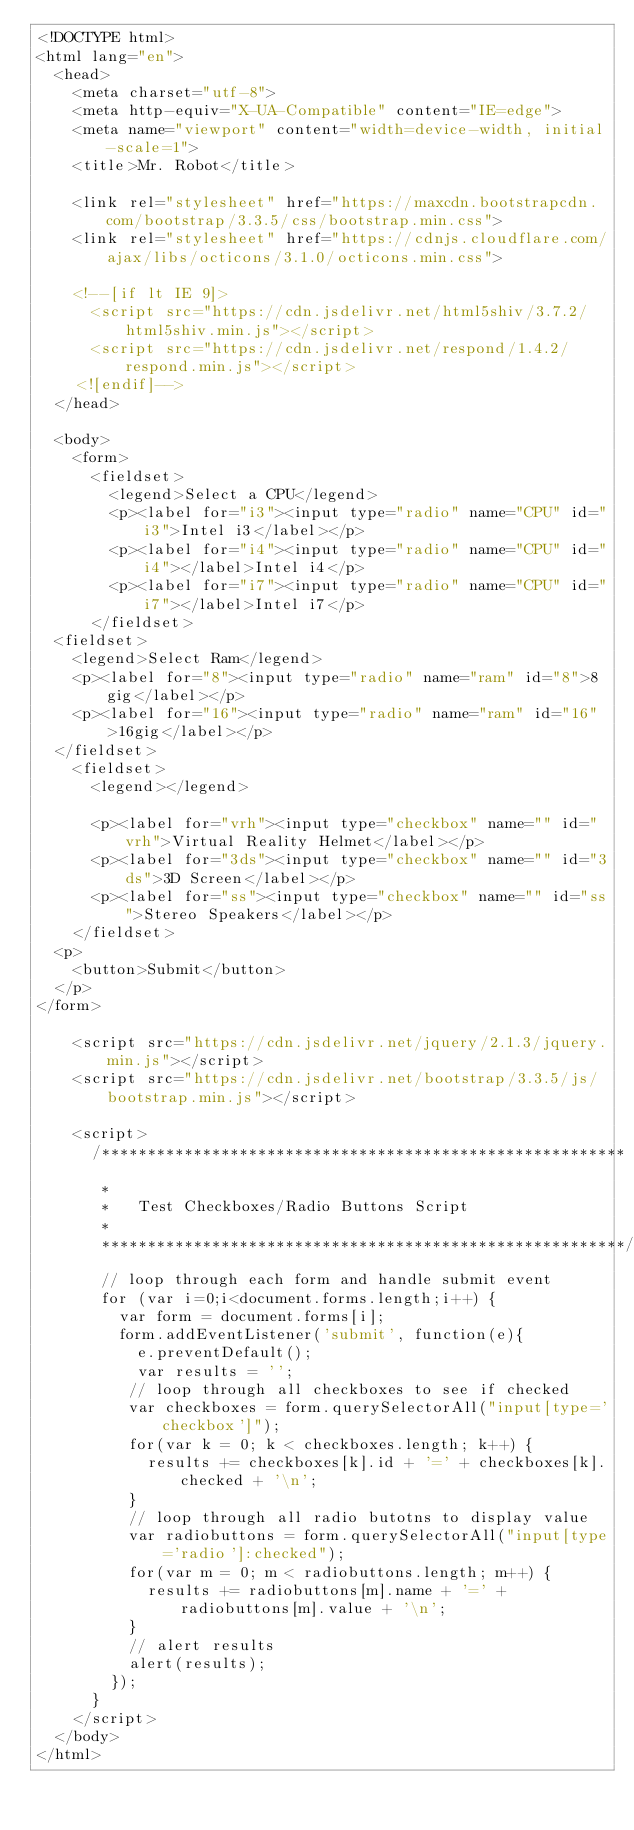<code> <loc_0><loc_0><loc_500><loc_500><_HTML_><!DOCTYPE html>
<html lang="en">
  <head>
    <meta charset="utf-8">
    <meta http-equiv="X-UA-Compatible" content="IE=edge">
    <meta name="viewport" content="width=device-width, initial-scale=1">
    <title>Mr. Robot</title>

    <link rel="stylesheet" href="https://maxcdn.bootstrapcdn.com/bootstrap/3.3.5/css/bootstrap.min.css">
    <link rel="stylesheet" href="https://cdnjs.cloudflare.com/ajax/libs/octicons/3.1.0/octicons.min.css">

    <!--[if lt IE 9]>
      <script src="https://cdn.jsdelivr.net/html5shiv/3.7.2/html5shiv.min.js"></script>
      <script src="https://cdn.jsdelivr.net/respond/1.4.2/respond.min.js"></script>
    <![endif]-->
  </head>

  <body>
    <form>
      <fieldset>
        <legend>Select a CPU</legend>
        <p><label for="i3"><input type="radio" name="CPU" id="i3">Intel i3</label></p>
        <p><label for="i4"><input type="radio" name="CPU" id="i4"></label>Intel i4</p>
        <p><label for="i7"><input type="radio" name="CPU" id="i7"></label>Intel i7</p>
      </fieldset>
  <fieldset>
    <legend>Select Ram</legend>
    <p><label for="8"><input type="radio" name="ram" id="8">8gig</label></p>
    <p><label for="16"><input type="radio" name="ram" id="16">16gig</label></p>
  </fieldset>
    <fieldset>
      <legend></legend>

      <p><label for="vrh"><input type="checkbox" name="" id="vrh">Virtual Reality Helmet</label></p>
      <p><label for="3ds"><input type="checkbox" name="" id="3ds">3D Screen</label></p>
      <p><label for="ss"><input type="checkbox" name="" id="ss">Stereo Speakers</label></p>
    </fieldset>
  <p>
    <button>Submit</button>
  </p>
</form>

    <script src="https://cdn.jsdelivr.net/jquery/2.1.3/jquery.min.js"></script>
    <script src="https://cdn.jsdelivr.net/bootstrap/3.3.5/js/bootstrap.min.js"></script>

    <script>
      /*********************************************************
       *
       *   Test Checkboxes/Radio Buttons Script
       *
       *********************************************************/
       // loop through each form and handle submit event
       for (var i=0;i<document.forms.length;i++) {
         var form = document.forms[i];
         form.addEventListener('submit', function(e){
           e.preventDefault();
           var results = '';
          // loop through all checkboxes to see if checked
          var checkboxes = form.querySelectorAll("input[type='checkbox']");
          for(var k = 0; k < checkboxes.length; k++) {
            results += checkboxes[k].id + '=' + checkboxes[k].checked + '\n';
          }
          // loop through all radio butotns to display value
          var radiobuttons = form.querySelectorAll("input[type='radio']:checked");
          for(var m = 0; m < radiobuttons.length; m++) {
            results += radiobuttons[m].name + '=' + radiobuttons[m].value + '\n';
          }
          // alert results
          alert(results);
        });
      }
    </script>
  </body>
</html>
</code> 